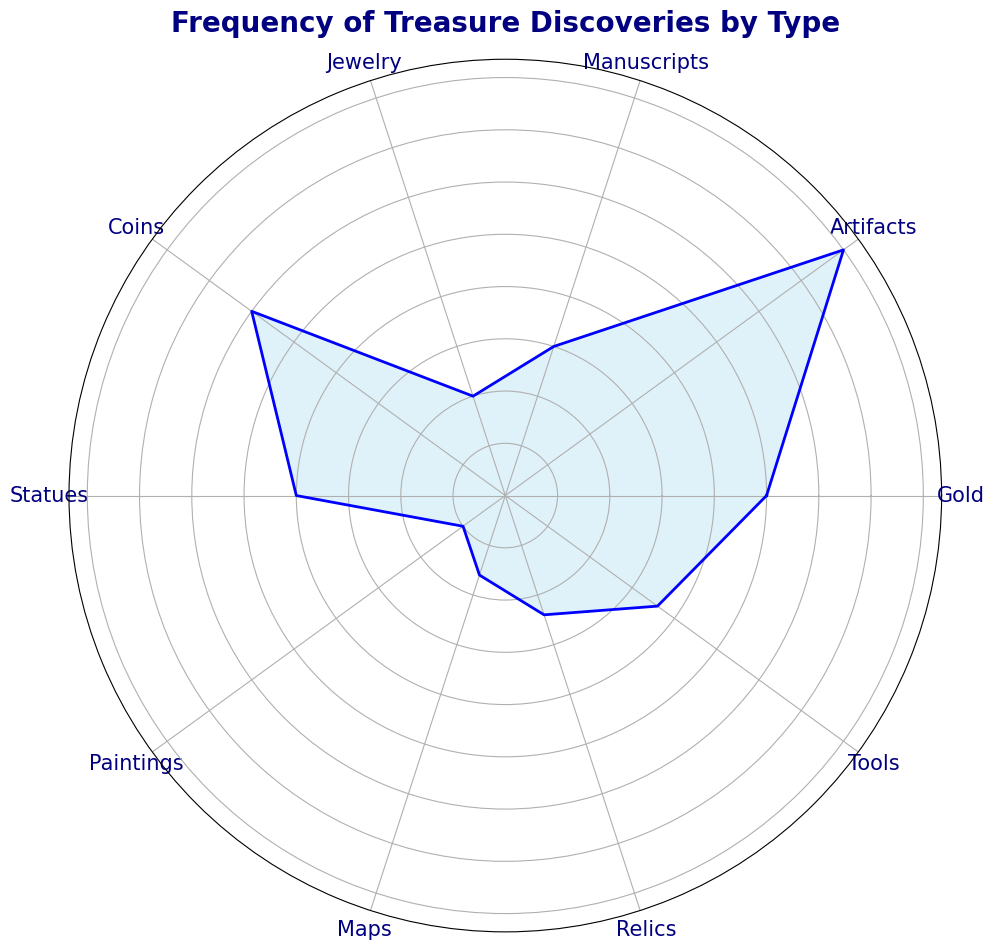What's the most frequently discovered type of treasure? The most frequently discovered type of treasure is the one with the longest bar in the rose chart. By examining the chart, we can see that 'Artifacts' has the longest segment.
Answer: Artifacts Which type of treasure is the least frequently discovered? The least frequently discovered type of treasure is represented by the shortest bar on the chart. From the chart, 'Paintings' appears to have the shortest segment.
Answer: Paintings How many types of treasures have a frequency of 20 or more discoveries? To determine this, we need to count all the segments whose length corresponds to a frequency of 20 or more. From the chart, 'Gold', 'Artifacts', 'Coins', and 'Statues' each have a frequency of 20 or more.
Answer: 4 Which two types of treasures have the closest frequencies? We need to identify the two segments that are closest in length. From the chart, 'Relics' (12) and 'Jewelry' (10) have the closest frequencies.
Answer: Relics and Jewelry What is the total frequency of all treasure discoveries combined? We need to sum up the frequencies of all the treasure types listed: Gold (25) + Artifacts (40) + Manuscripts (15) + Jewelry (10) + Coins (30) + Statues (20) + Paintings (5) + Maps (8) + Relics (12) + Tools (18) = 183.
Answer: 183 How much more frequent are discoveries of Coins compared to Manuscripts? We need to find the difference between the frequencies of Coins and Manuscripts. Coins have a frequency of 30 and Manuscripts have a frequency of 15. The difference is 30 - 15.
Answer: 15 Are discoveries of Statues more or less frequent than discoveries of Gold? We need to compare the lengths of the 'Statues' and 'Gold' segments. Statues (20) is less than Gold (25).
Answer: Less Which type of treasure discoveries fall between Tools and Relics in terms of frequency? We need to find the frequency values for Tools (18) and Relics (12) and identify any treasures with frequencies between these two values. 'Maps' has a frequency (8) that falls between Tools and Relics.
Answer: Maps What is the average frequency of discoveries for all the types of treasures shown? To find the average frequency, sum all the values and divide by the number of types: (25 + 40 + 15 + 10 + 30 + 20 + 5 + 8 + 12 + 18) / 10 = 183 / 10.
Answer: 18.3 Which type of treasure is discovered more frequently, Maps or Tools? By comparing the lengths of the segments 'Maps' and 'Tools', we see that Tools (18) is longer than Maps (8).
Answer: Tools 